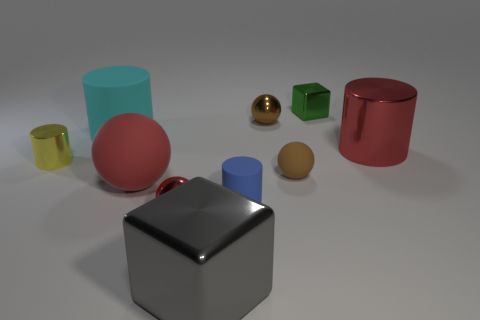Subtract 1 spheres. How many spheres are left? 3 Subtract all cubes. How many objects are left? 8 Subtract 0 gray spheres. How many objects are left? 10 Subtract all red matte things. Subtract all small green rubber cubes. How many objects are left? 9 Add 3 tiny brown shiny balls. How many tiny brown shiny balls are left? 4 Add 6 red cylinders. How many red cylinders exist? 7 